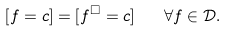<formula> <loc_0><loc_0><loc_500><loc_500>[ f = c ] = [ f ^ { \square } = c ] \quad \forall f \in \mathcal { D } .</formula> 